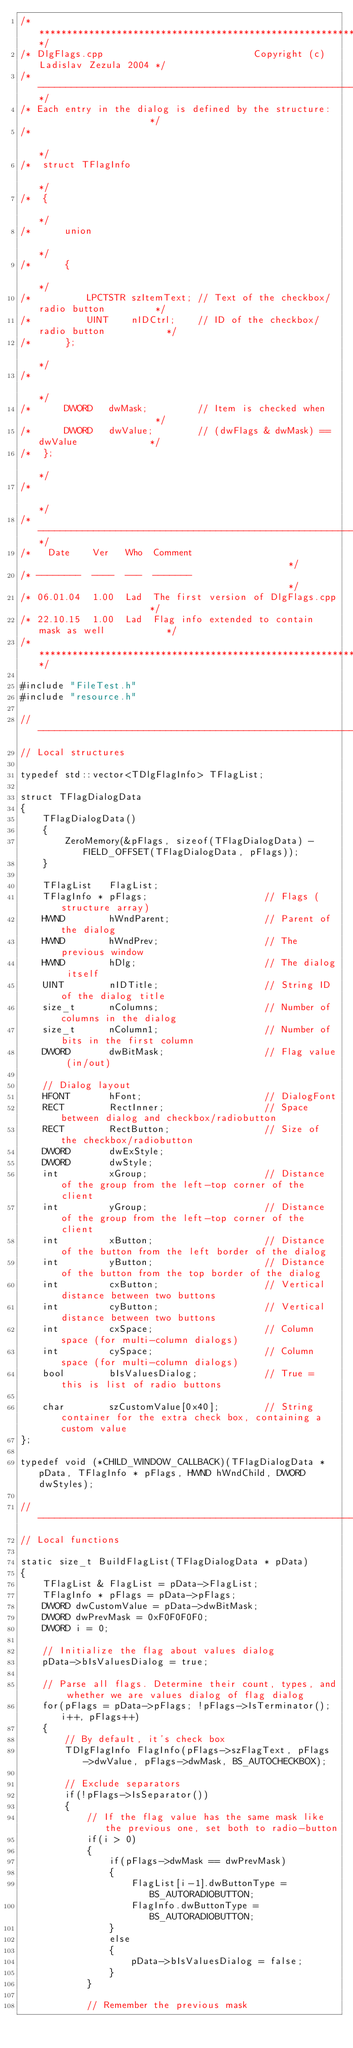Convert code to text. <code><loc_0><loc_0><loc_500><loc_500><_C++_>/*****************************************************************************/
/* DlgFlags.cpp                           Copyright (c) Ladislav Zezula 2004 */
/*---------------------------------------------------------------------------*/
/* Each entry in the dialog is defined by the structure:                     */
/*                                                                           */
/*  struct TFlagInfo                                                         */
/*  {                                                                        */
/*      union                                                                */
/*      {                                                                    */
/*          LPCTSTR szItemText; // Text of the checkbox/radio button         */
/*          UINT    nIDCtrl;    // ID of the checkbox/radio button           */
/*      };                                                                   */
/*                                                                           */
/*      DWORD   dwMask;         // Item is checked when                      */
/*      DWORD   dwValue;        // (dwFlags & dwMask) == dwValue             */
/*  };                                                                       */
/*                                                                           */
/*---------------------------------------------------------------------------*/
/*   Date    Ver   Who  Comment                                              */
/* --------  ----  ---  -------                                              */
/* 06.01.04  1.00  Lad  The first version of DlgFlags.cpp                    */
/* 22.10.15  1.00  Lad  Flag info extended to contain mask as well           */
/*****************************************************************************/

#include "FileTest.h"
#include "resource.h"

//-----------------------------------------------------------------------------
// Local structures

typedef std::vector<TDlgFlagInfo> TFlagList;

struct TFlagDialogData
{
    TFlagDialogData()
    {
        ZeroMemory(&pFlags, sizeof(TFlagDialogData) - FIELD_OFFSET(TFlagDialogData, pFlags));
    }

    TFlagList   FlagList;
    TFlagInfo * pFlags;                     // Flags (structure array)
    HWND        hWndParent;                 // Parent of the dialog
    HWND        hWndPrev;                   // The previous window
    HWND        hDlg;                       // The dialog itself
    UINT        nIDTitle;                   // String ID of the dialog title
    size_t      nColumns;                   // Number of columns in the dialog
    size_t      nColumn1;                   // Number of bits in the first column
    DWORD       dwBitMask;                  // Flag value (in/out)

    // Dialog layout
    HFONT       hFont;                      // DialogFont
    RECT        RectInner;                  // Space between dialog and checkbox/radiobutton
    RECT        RectButton;                 // Size of the checkbox/radiobutton
    DWORD       dwExStyle;
    DWORD       dwStyle;
    int         xGroup;                     // Distance of the group from the left-top corner of the client
    int         yGroup;                     // Distance of the group from the left-top corner of the client
    int         xButton;                    // Distance of the button from the left border of the dialog
    int         yButton;                    // Distance of the button from the top border of the dialog
    int         cxButton;                   // Vertical distance between two buttons
    int         cyButton;                   // Vertical distance between two buttons
    int         cxSpace;                    // Column space (for multi-column dialogs)
    int         cySpace;                    // Column space (for multi-column dialogs)
    bool        bIsValuesDialog;            // True = this is list of radio buttons

    char        szCustomValue[0x40];        // String container for the extra check box, containing a custom value
};

typedef void (*CHILD_WINDOW_CALLBACK)(TFlagDialogData * pData, TFlagInfo * pFlags, HWND hWndChild, DWORD dwStyles);

//-----------------------------------------------------------------------------
// Local functions

static size_t BuildFlagList(TFlagDialogData * pData)
{
    TFlagList & FlagList = pData->FlagList;
    TFlagInfo * pFlags = pData->pFlags;
    DWORD dwCustomValue = pData->dwBitMask;
    DWORD dwPrevMask = 0xF0F0F0F0;
    DWORD i = 0;

    // Initialize the flag about values dialog
    pData->bIsValuesDialog = true;

    // Parse all flags. Determine their count, types, and whether we are values dialog of flag dialog
    for(pFlags = pData->pFlags; !pFlags->IsTerminator(); i++, pFlags++)
    {
        // By default, it's check box
        TDlgFlagInfo FlagInfo(pFlags->szFlagText, pFlags->dwValue, pFlags->dwMask, BS_AUTOCHECKBOX);

        // Exclude separators
        if(!pFlags->IsSeparator())
        {
            // If the flag value has the same mask like the previous one, set both to radio-button
            if(i > 0)
            {
                if(pFlags->dwMask == dwPrevMask)
                {
                    FlagList[i-1].dwButtonType = BS_AUTORADIOBUTTON;
                    FlagInfo.dwButtonType = BS_AUTORADIOBUTTON;
                }
                else
                {
                    pData->bIsValuesDialog = false;
                }
            }

            // Remember the previous mask</code> 